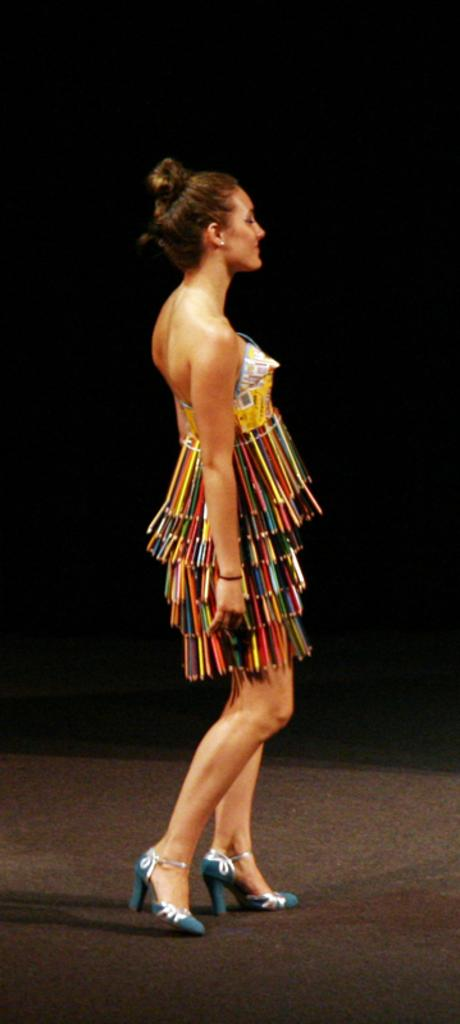Who is present in the image? There is a woman in the image. What is the woman doing in the image? The woman is standing in the image. What is the woman's facial expression in the image? The woman is smiling in the image. What type of floor can be seen in the image? There is no information about the floor in the image, as the focus is on the woman. 